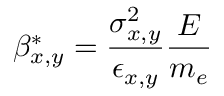Convert formula to latex. <formula><loc_0><loc_0><loc_500><loc_500>\beta _ { x , y } ^ { * } = \frac { \sigma _ { x , y } ^ { 2 } } { \epsilon _ { x , y } } \frac { E } { m _ { e } }</formula> 